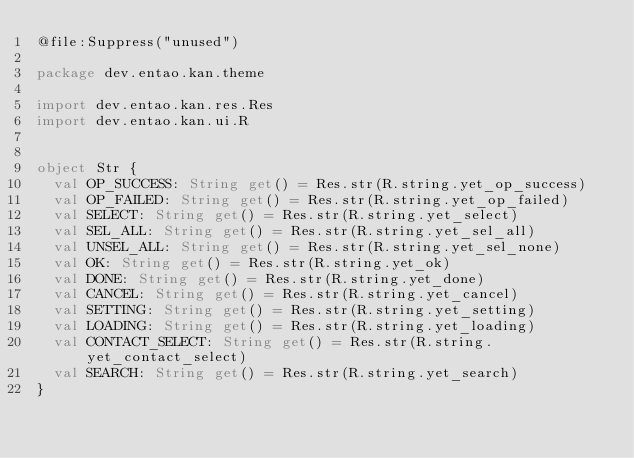Convert code to text. <code><loc_0><loc_0><loc_500><loc_500><_Kotlin_>@file:Suppress("unused")

package dev.entao.kan.theme

import dev.entao.kan.res.Res
import dev.entao.kan.ui.R


object Str {
	val OP_SUCCESS: String get() = Res.str(R.string.yet_op_success)
	val OP_FAILED: String get() = Res.str(R.string.yet_op_failed)
	val SELECT: String get() = Res.str(R.string.yet_select)
	val SEL_ALL: String get() = Res.str(R.string.yet_sel_all)
	val UNSEL_ALL: String get() = Res.str(R.string.yet_sel_none)
	val OK: String get() = Res.str(R.string.yet_ok)
	val DONE: String get() = Res.str(R.string.yet_done)
	val CANCEL: String get() = Res.str(R.string.yet_cancel)
	val SETTING: String get() = Res.str(R.string.yet_setting)
	val LOADING: String get() = Res.str(R.string.yet_loading)
	val CONTACT_SELECT: String get() = Res.str(R.string.yet_contact_select)
	val SEARCH: String get() = Res.str(R.string.yet_search)
}
</code> 